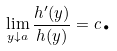Convert formula to latex. <formula><loc_0><loc_0><loc_500><loc_500>\lim _ { y \downarrow a } \frac { h ^ { \prime } ( y ) } { h ( y ) } = c \text {.}</formula> 